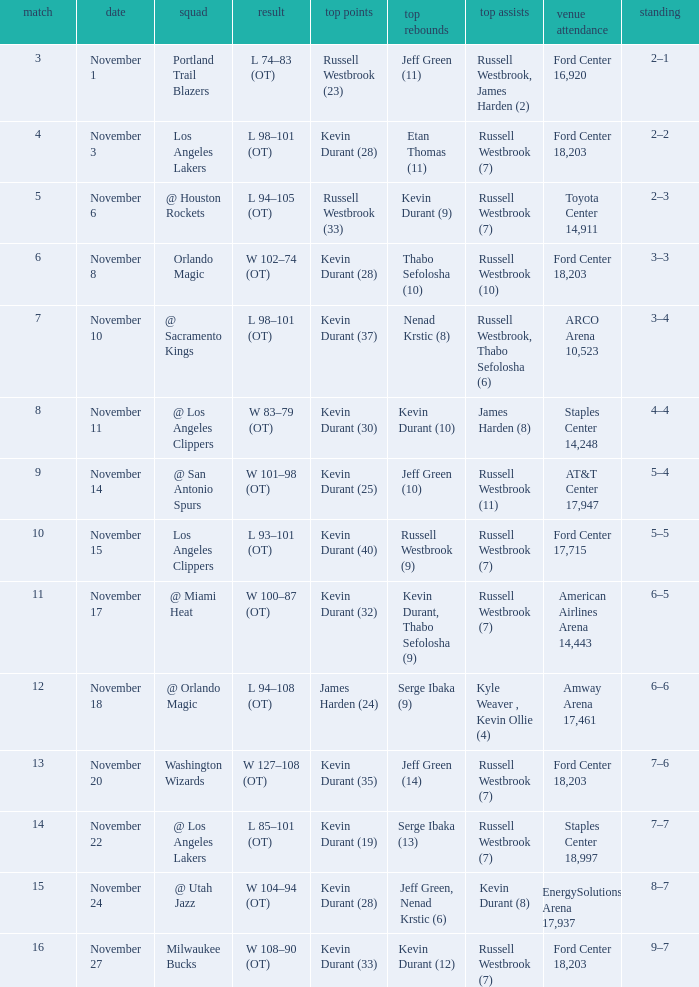What was the record in the game in which Jeff Green (14) did the most high rebounds? 7–6. Help me parse the entirety of this table. {'header': ['match', 'date', 'squad', 'result', 'top points', 'top rebounds', 'top assists', 'venue attendance', 'standing'], 'rows': [['3', 'November 1', 'Portland Trail Blazers', 'L 74–83 (OT)', 'Russell Westbrook (23)', 'Jeff Green (11)', 'Russell Westbrook, James Harden (2)', 'Ford Center 16,920', '2–1'], ['4', 'November 3', 'Los Angeles Lakers', 'L 98–101 (OT)', 'Kevin Durant (28)', 'Etan Thomas (11)', 'Russell Westbrook (7)', 'Ford Center 18,203', '2–2'], ['5', 'November 6', '@ Houston Rockets', 'L 94–105 (OT)', 'Russell Westbrook (33)', 'Kevin Durant (9)', 'Russell Westbrook (7)', 'Toyota Center 14,911', '2–3'], ['6', 'November 8', 'Orlando Magic', 'W 102–74 (OT)', 'Kevin Durant (28)', 'Thabo Sefolosha (10)', 'Russell Westbrook (10)', 'Ford Center 18,203', '3–3'], ['7', 'November 10', '@ Sacramento Kings', 'L 98–101 (OT)', 'Kevin Durant (37)', 'Nenad Krstic (8)', 'Russell Westbrook, Thabo Sefolosha (6)', 'ARCO Arena 10,523', '3–4'], ['8', 'November 11', '@ Los Angeles Clippers', 'W 83–79 (OT)', 'Kevin Durant (30)', 'Kevin Durant (10)', 'James Harden (8)', 'Staples Center 14,248', '4–4'], ['9', 'November 14', '@ San Antonio Spurs', 'W 101–98 (OT)', 'Kevin Durant (25)', 'Jeff Green (10)', 'Russell Westbrook (11)', 'AT&T Center 17,947', '5–4'], ['10', 'November 15', 'Los Angeles Clippers', 'L 93–101 (OT)', 'Kevin Durant (40)', 'Russell Westbrook (9)', 'Russell Westbrook (7)', 'Ford Center 17,715', '5–5'], ['11', 'November 17', '@ Miami Heat', 'W 100–87 (OT)', 'Kevin Durant (32)', 'Kevin Durant, Thabo Sefolosha (9)', 'Russell Westbrook (7)', 'American Airlines Arena 14,443', '6–5'], ['12', 'November 18', '@ Orlando Magic', 'L 94–108 (OT)', 'James Harden (24)', 'Serge Ibaka (9)', 'Kyle Weaver , Kevin Ollie (4)', 'Amway Arena 17,461', '6–6'], ['13', 'November 20', 'Washington Wizards', 'W 127–108 (OT)', 'Kevin Durant (35)', 'Jeff Green (14)', 'Russell Westbrook (7)', 'Ford Center 18,203', '7–6'], ['14', 'November 22', '@ Los Angeles Lakers', 'L 85–101 (OT)', 'Kevin Durant (19)', 'Serge Ibaka (13)', 'Russell Westbrook (7)', 'Staples Center 18,997', '7–7'], ['15', 'November 24', '@ Utah Jazz', 'W 104–94 (OT)', 'Kevin Durant (28)', 'Jeff Green, Nenad Krstic (6)', 'Kevin Durant (8)', 'EnergySolutions Arena 17,937', '8–7'], ['16', 'November 27', 'Milwaukee Bucks', 'W 108–90 (OT)', 'Kevin Durant (33)', 'Kevin Durant (12)', 'Russell Westbrook (7)', 'Ford Center 18,203', '9–7']]} 